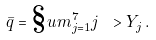<formula> <loc_0><loc_0><loc_500><loc_500>\bar { q } = \S u m _ { j = 1 } ^ { 7 } j \ > Y _ { j } \, .</formula> 